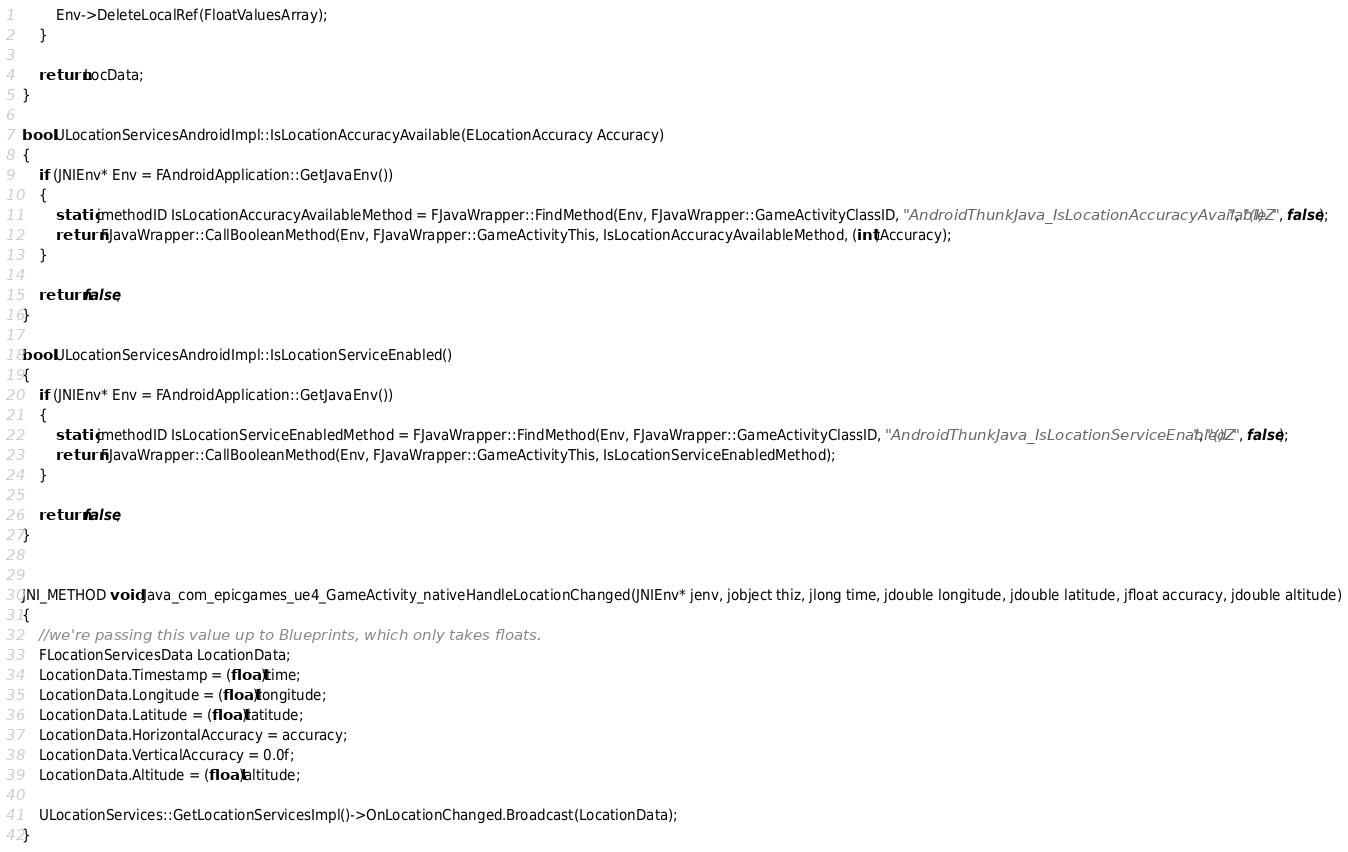<code> <loc_0><loc_0><loc_500><loc_500><_C++_>		Env->DeleteLocalRef(FloatValuesArray);
	}

	return LocData;
}

bool ULocationServicesAndroidImpl::IsLocationAccuracyAvailable(ELocationAccuracy Accuracy)
{
	if (JNIEnv* Env = FAndroidApplication::GetJavaEnv())
	{
		static jmethodID IsLocationAccuracyAvailableMethod = FJavaWrapper::FindMethod(Env, FJavaWrapper::GameActivityClassID, "AndroidThunkJava_IsLocationAccuracyAvailable", "(I)Z", false);
		return FJavaWrapper::CallBooleanMethod(Env, FJavaWrapper::GameActivityThis, IsLocationAccuracyAvailableMethod, (int)Accuracy);
	}

	return false;
}
	
bool ULocationServicesAndroidImpl::IsLocationServiceEnabled()
{
	if (JNIEnv* Env = FAndroidApplication::GetJavaEnv())
	{
		static jmethodID IsLocationServiceEnabledMethod = FJavaWrapper::FindMethod(Env, FJavaWrapper::GameActivityClassID, "AndroidThunkJava_IsLocationServiceEnabled", "()Z", false);
		return FJavaWrapper::CallBooleanMethod(Env, FJavaWrapper::GameActivityThis, IsLocationServiceEnabledMethod);
	}

	return false;
}


JNI_METHOD void Java_com_epicgames_ue4_GameActivity_nativeHandleLocationChanged(JNIEnv* jenv, jobject thiz, jlong time, jdouble longitude, jdouble latitude, jfloat accuracy, jdouble altitude)
{
	//we're passing this value up to Blueprints, which only takes floats.
	FLocationServicesData LocationData;
	LocationData.Timestamp = (float)time;
	LocationData.Longitude = (float)longitude;
	LocationData.Latitude = (float)latitude;
	LocationData.HorizontalAccuracy = accuracy;
	LocationData.VerticalAccuracy = 0.0f;
	LocationData.Altitude = (float)altitude;

	ULocationServices::GetLocationServicesImpl()->OnLocationChanged.Broadcast(LocationData);
}</code> 